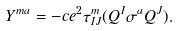<formula> <loc_0><loc_0><loc_500><loc_500>Y ^ { m a } = - c e ^ { 2 } \tau ^ { m } _ { I J } ( Q ^ { I } \sigma ^ { a } Q ^ { J } ) .</formula> 